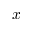Convert formula to latex. <formula><loc_0><loc_0><loc_500><loc_500>x</formula> 